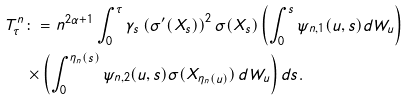<formula> <loc_0><loc_0><loc_500><loc_500>T ^ { n } _ { \tau } & \colon = n ^ { 2 \alpha + 1 } \int ^ { \tau } _ { 0 } \gamma _ { s } \left ( \sigma ^ { \prime } ( X _ { s } ) \right ) ^ { 2 } \sigma ( X _ { s } ) \left ( \int _ { 0 } ^ { s } \psi _ { n , 1 } ( u , s ) d W _ { u } \right ) \\ & \times \left ( \int _ { 0 } ^ { \eta _ { n } ( s ) } \psi _ { n , 2 } ( u , s ) \sigma ( X _ { \eta _ { n } ( u ) } ) \, d W _ { u } \right ) d s .</formula> 